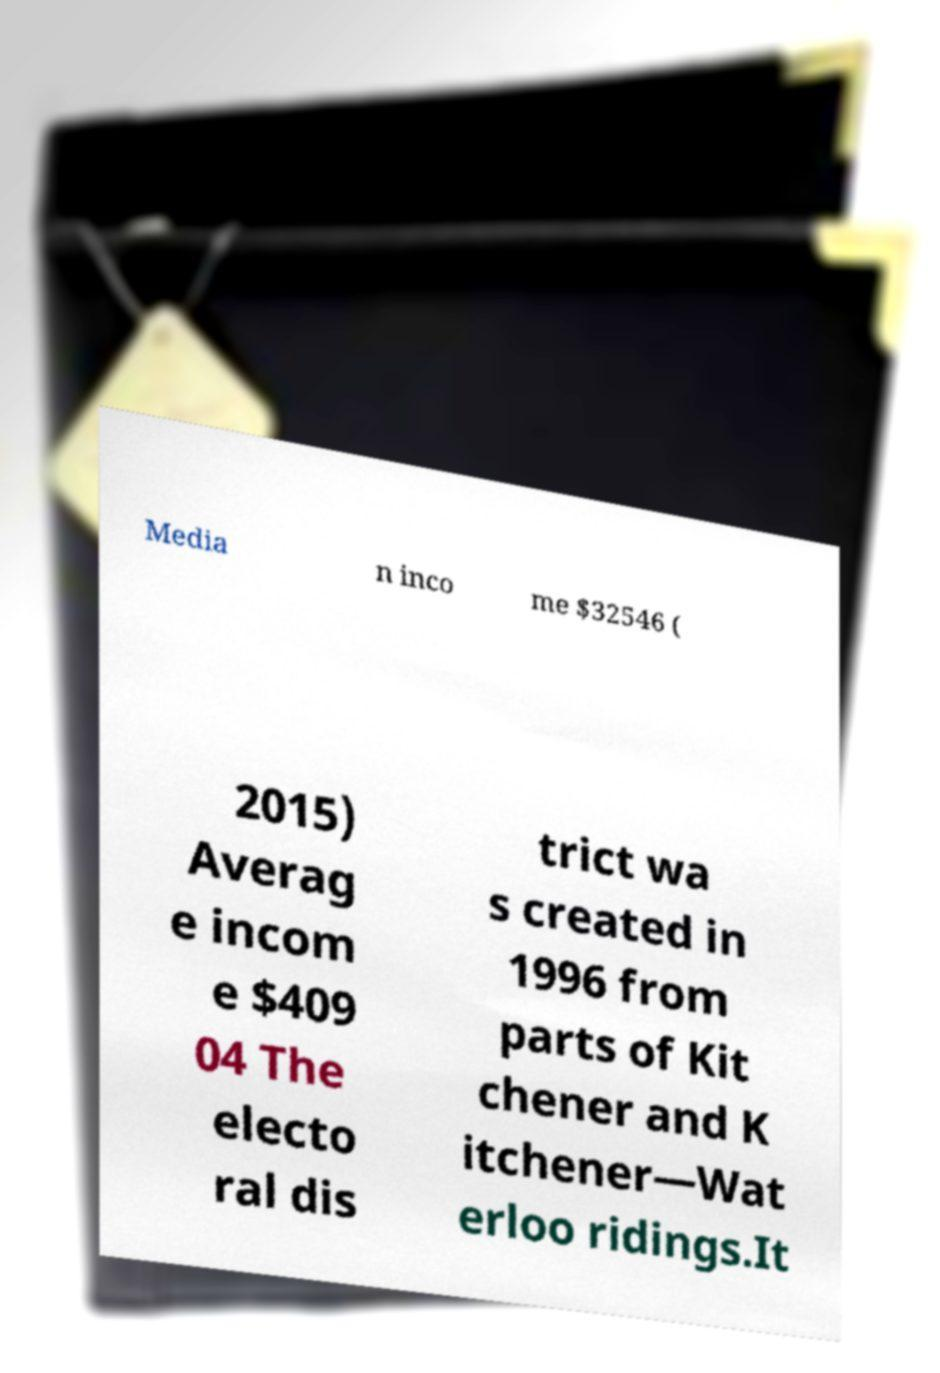For documentation purposes, I need the text within this image transcribed. Could you provide that? Media n inco me $32546 ( 2015) Averag e incom e $409 04 The electo ral dis trict wa s created in 1996 from parts of Kit chener and K itchener—Wat erloo ridings.It 